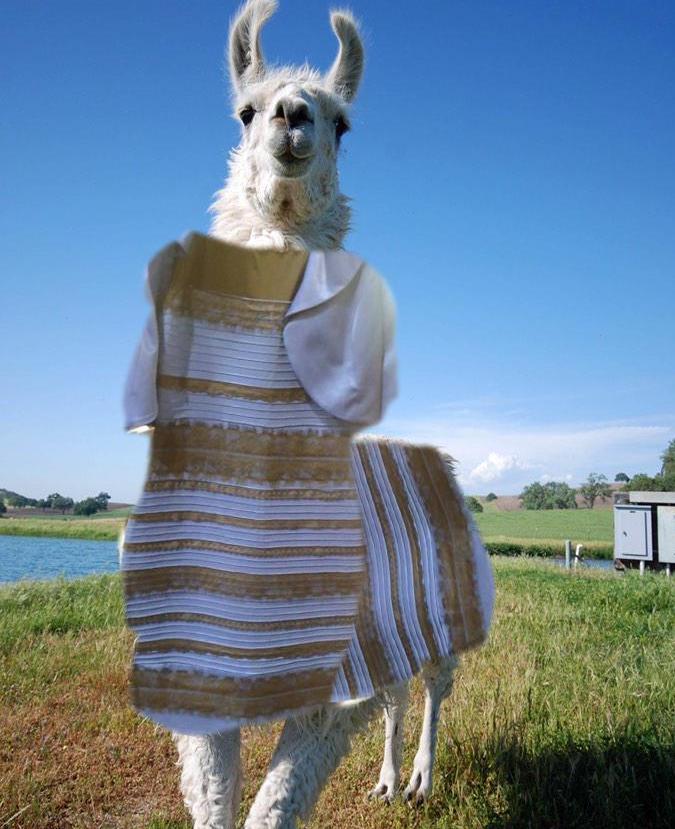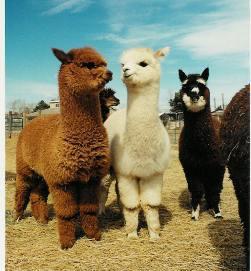The first image is the image on the left, the second image is the image on the right. Assess this claim about the two images: "There are exactly four llamas.". Correct or not? Answer yes or no. No. The first image is the image on the left, the second image is the image on the right. Evaluate the accuracy of this statement regarding the images: "Each image shows exactly two llamas posed close together in the foreground, and a mountain peak is visible in the background of the left image.". Is it true? Answer yes or no. No. 